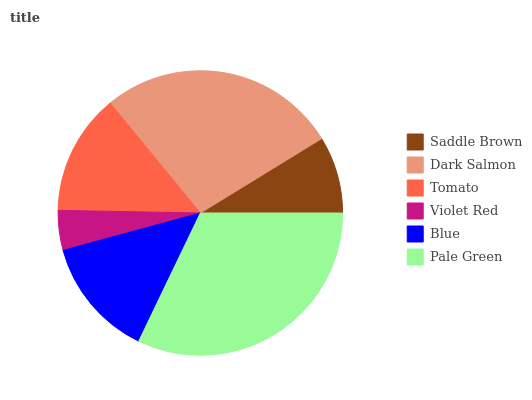Is Violet Red the minimum?
Answer yes or no. Yes. Is Pale Green the maximum?
Answer yes or no. Yes. Is Dark Salmon the minimum?
Answer yes or no. No. Is Dark Salmon the maximum?
Answer yes or no. No. Is Dark Salmon greater than Saddle Brown?
Answer yes or no. Yes. Is Saddle Brown less than Dark Salmon?
Answer yes or no. Yes. Is Saddle Brown greater than Dark Salmon?
Answer yes or no. No. Is Dark Salmon less than Saddle Brown?
Answer yes or no. No. Is Tomato the high median?
Answer yes or no. Yes. Is Blue the low median?
Answer yes or no. Yes. Is Saddle Brown the high median?
Answer yes or no. No. Is Violet Red the low median?
Answer yes or no. No. 